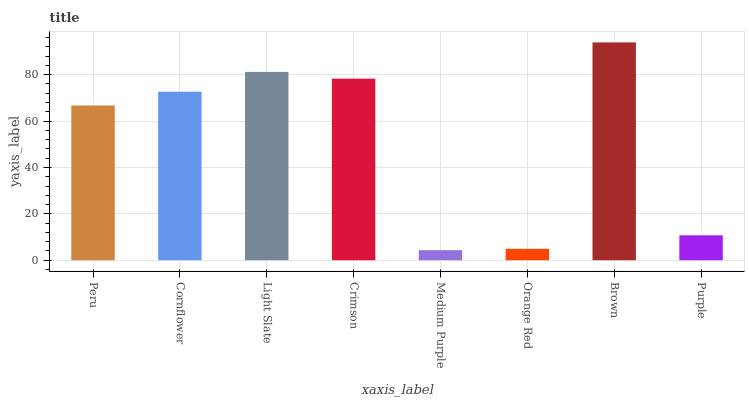Is Medium Purple the minimum?
Answer yes or no. Yes. Is Brown the maximum?
Answer yes or no. Yes. Is Cornflower the minimum?
Answer yes or no. No. Is Cornflower the maximum?
Answer yes or no. No. Is Cornflower greater than Peru?
Answer yes or no. Yes. Is Peru less than Cornflower?
Answer yes or no. Yes. Is Peru greater than Cornflower?
Answer yes or no. No. Is Cornflower less than Peru?
Answer yes or no. No. Is Cornflower the high median?
Answer yes or no. Yes. Is Peru the low median?
Answer yes or no. Yes. Is Peru the high median?
Answer yes or no. No. Is Light Slate the low median?
Answer yes or no. No. 